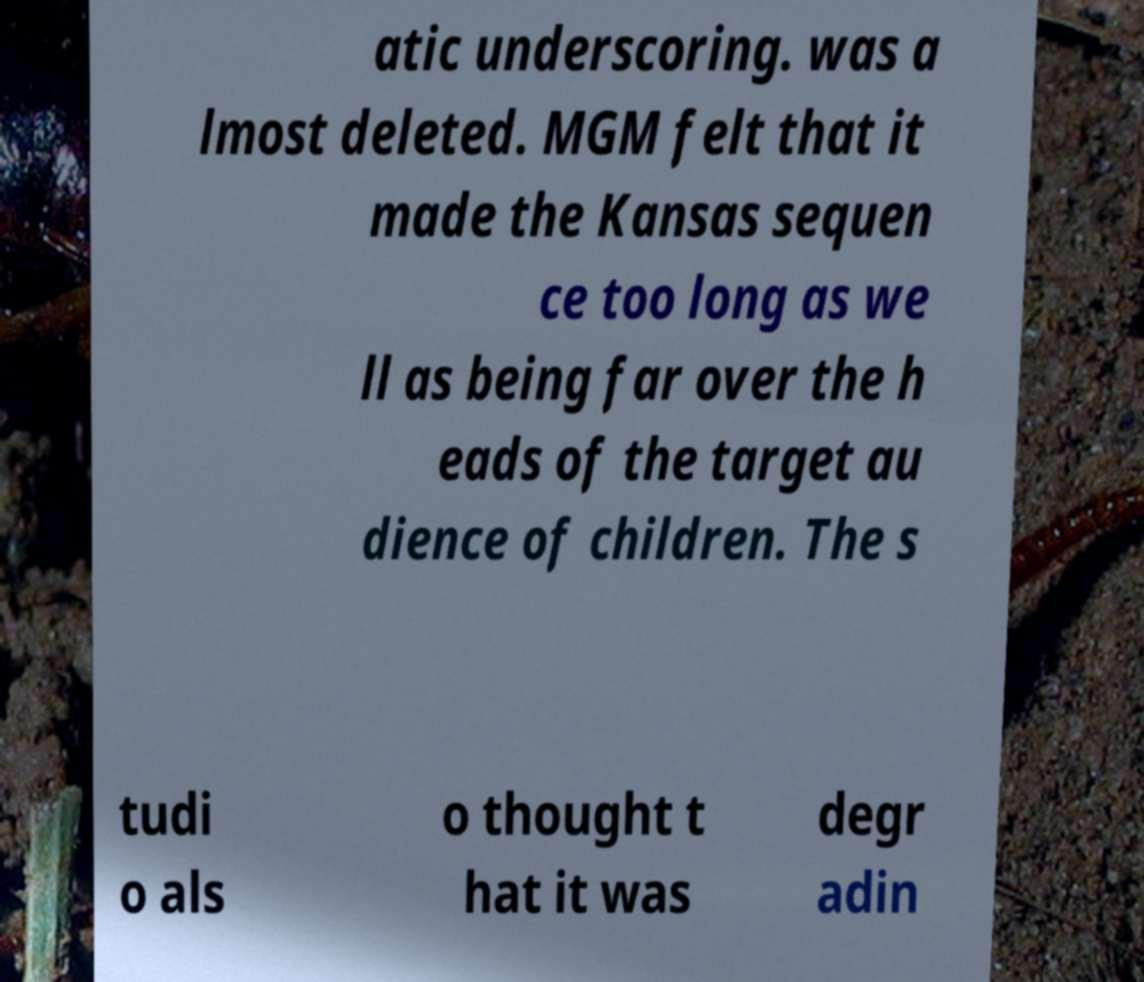What messages or text are displayed in this image? I need them in a readable, typed format. atic underscoring. was a lmost deleted. MGM felt that it made the Kansas sequen ce too long as we ll as being far over the h eads of the target au dience of children. The s tudi o als o thought t hat it was degr adin 